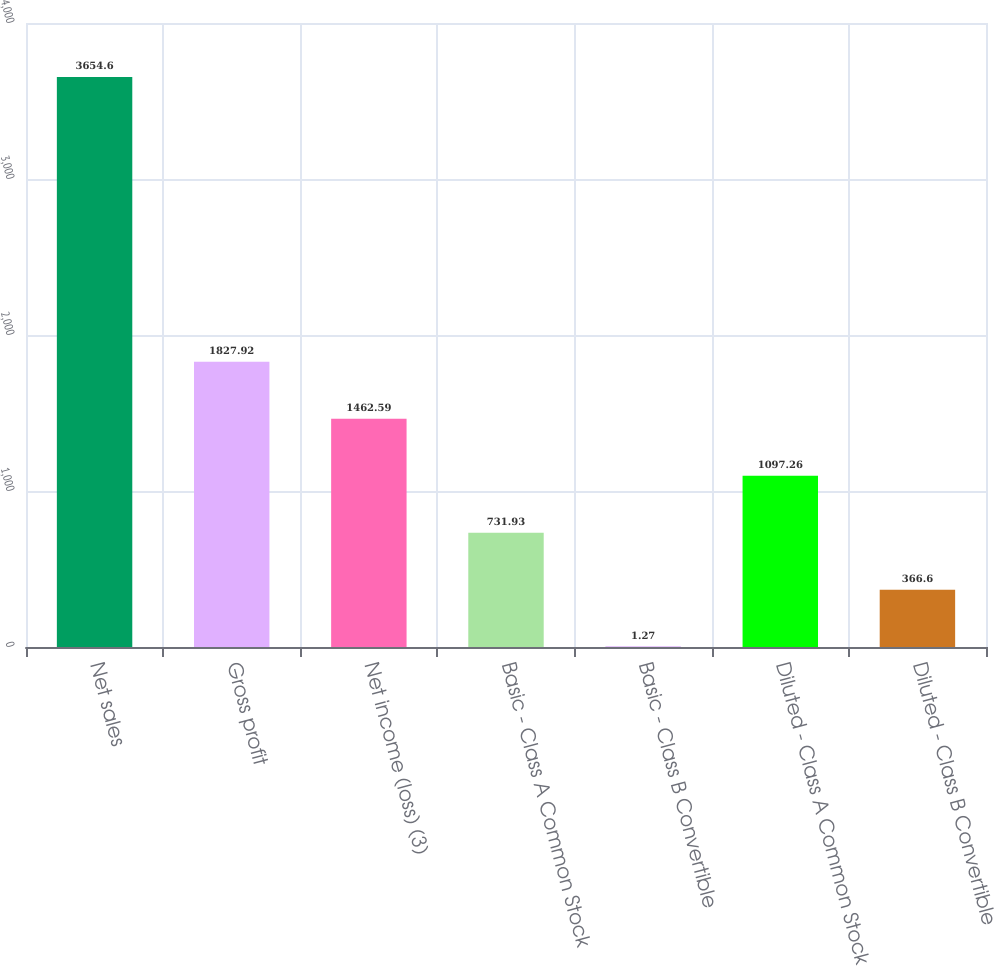Convert chart to OTSL. <chart><loc_0><loc_0><loc_500><loc_500><bar_chart><fcel>Net sales<fcel>Gross profit<fcel>Net income (loss) (3)<fcel>Basic - Class A Common Stock<fcel>Basic - Class B Convertible<fcel>Diluted - Class A Common Stock<fcel>Diluted - Class B Convertible<nl><fcel>3654.6<fcel>1827.92<fcel>1462.59<fcel>731.93<fcel>1.27<fcel>1097.26<fcel>366.6<nl></chart> 